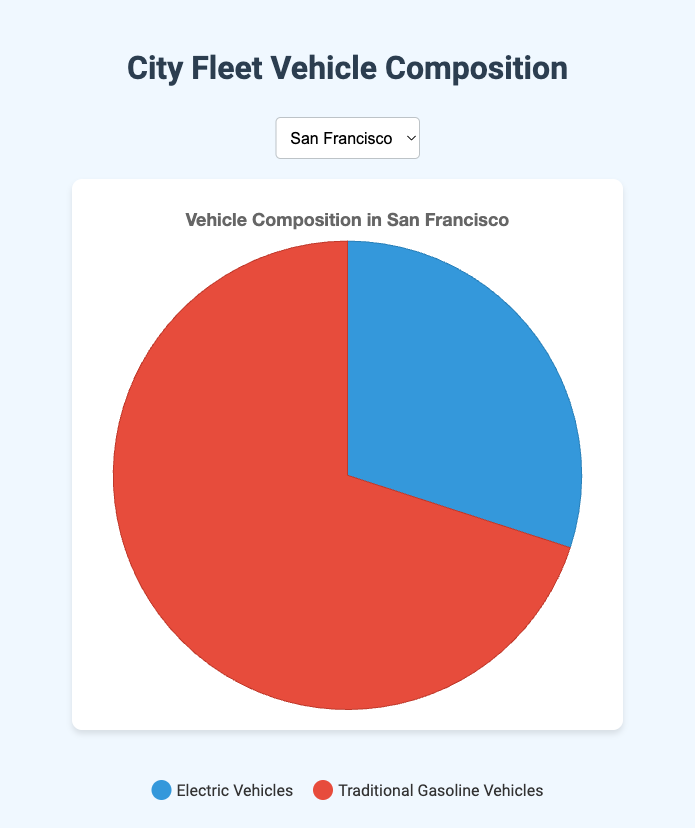What are the components shown in the pie chart for each city? The pie chart shows two components for the vehicle fleet composition in each city: the proportion of electric vehicles and the proportion of traditional gasoline vehicles. The percentages for each can be directly read from the chart.
Answer: Electric Vehicles, Traditional Gasoline Vehicles Which city has the highest proportion of electric vehicles? By examining the pie charts for each city, the city with the largest percentage for electric vehicles can be identified. In this case, Seattle has the highest proportion with 35% electric vehicles.
Answer: Seattle How much greater is the proportion of traditional gasoline vehicles in New York compared to Seattle? To find the difference, subtract the percentage of traditional gasoline vehicles in Seattle (65%) from that in New York (75%). So, 75% - 65% = 10%.
Answer: 10% If the goal is to have at least 30% electric vehicles, which cities do not meet this target? Any city with an electric vehicle proportion less than 30% does not meet the target. From the data, New York (25%), Los Angeles (28%), and Chicago (22%) do not meet the target.
Answer: New York, Los Angeles, Chicago What is the average percentage of electric vehicles across all the cities? Add up the percentages of electric vehicles in all cities and divide by the number of cities: (30 + 25 + 28 + 35 + 22) / 5 = 28%.
Answer: 28% For which city is the discrepancy between electric and traditional gasoline vehicles' proportions the smallest? Calculate the difference between the percentages of electric and traditional gasoline vehicles for each city and identify the smallest value. The differences are: San Francisco (40%), New York (50%), Los Angeles (44%), Seattle (30%), Chicago (56%). Seattle has the smallest discrepancy of 30%.
Answer: Seattle Which city has the most balanced composition between electric and traditional gasoline vehicles? The most balanced composition will have the smallest difference between the two percentages. As previously calculated, Seattle has the smallest difference of 30%.
Answer: Seattle How much more prevalent are traditional gasoline vehicles in Chicago compared to electric vehicles in Los Angeles? Subtract the percentage of electric vehicles in Los Angeles (28%) from the percentage of traditional gasoline vehicles in Chicago (78%): 78% - 28% = 50%.
Answer: 50% By what percentage does San Francisco need to increase its electric vehicle proportion to match Seattle's current percentage? Seattle has 35% electric vehicles, and San Francisco has 30%. The increase needed is 35% - 30% = 5%.
Answer: 5% If Chicago increased its electric vehicle proportion by 10%, would it surpass Los Angeles's current proportion? Adding 10% to Chicago's current electric vehicle proportion (22%) gives 32%. Since Los Angeles has 28%, Chicago would surpass Los Angeles.
Answer: Yes 